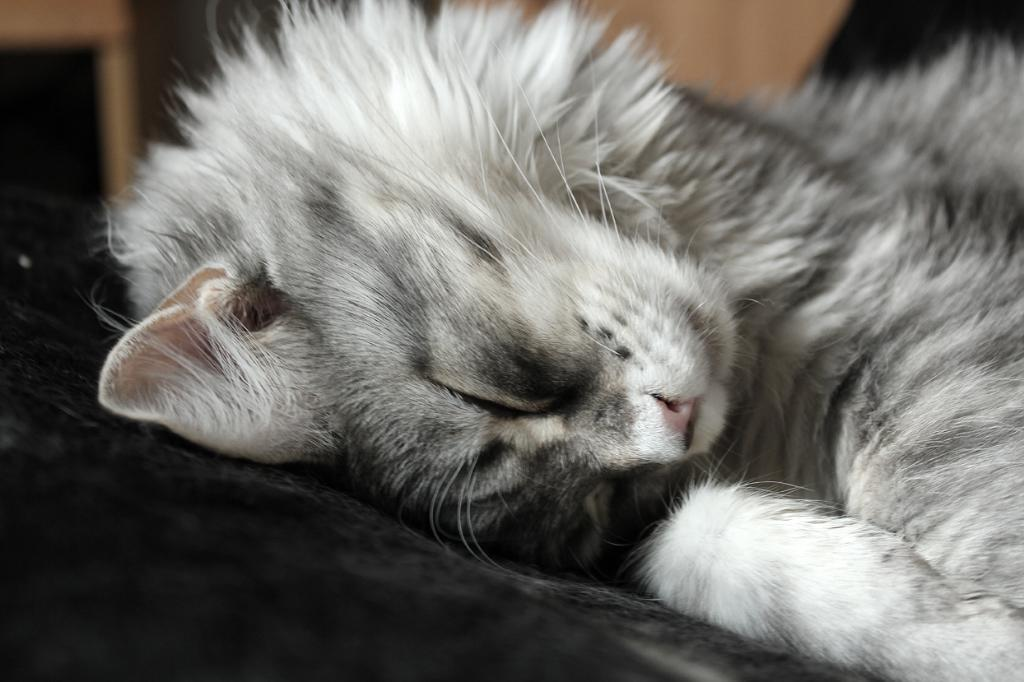What type of animal is in the image? There is a cat in the image. Where is the cat located? The cat is on a couch. How many snakes are slithering in the yard in the image? There are no snakes or yards present in the image; it features a cat on a couch. What type of fruit is the cat holding in the image? There is no fruit present in the image; it features a cat on a couch. 